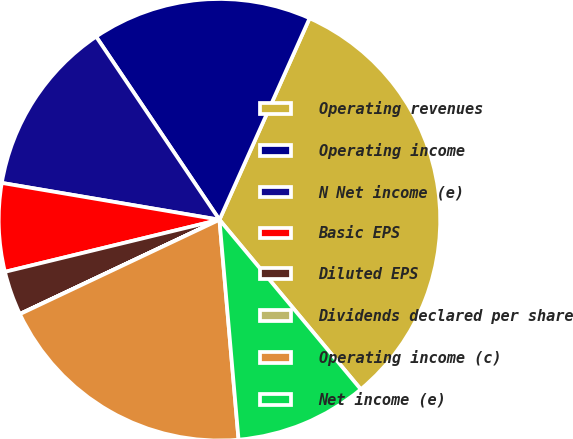<chart> <loc_0><loc_0><loc_500><loc_500><pie_chart><fcel>Operating revenues<fcel>Operating income<fcel>N Net income (e)<fcel>Basic EPS<fcel>Diluted EPS<fcel>Dividends declared per share<fcel>Operating income (c)<fcel>Net income (e)<nl><fcel>32.25%<fcel>16.13%<fcel>12.9%<fcel>6.46%<fcel>3.23%<fcel>0.01%<fcel>19.35%<fcel>9.68%<nl></chart> 